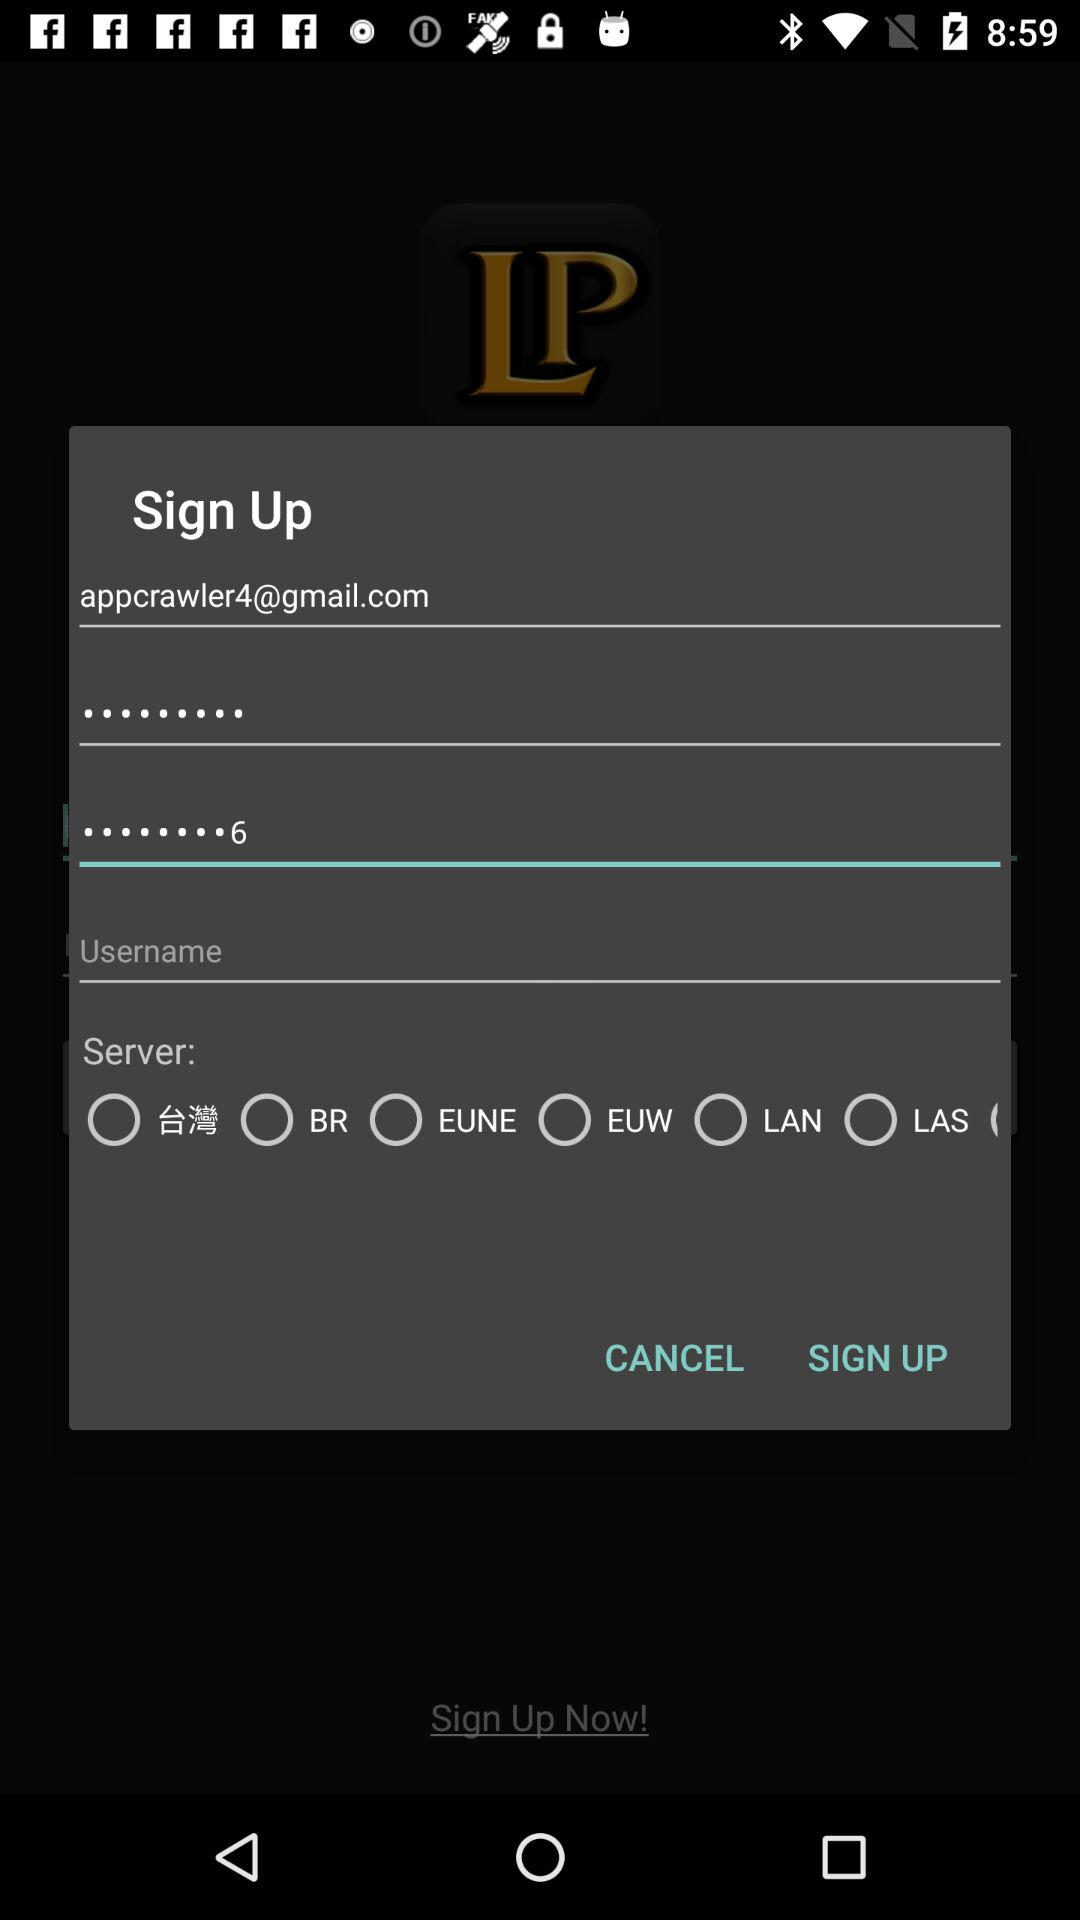What is the email address? The email address is appcrawler4@gmail.com. 